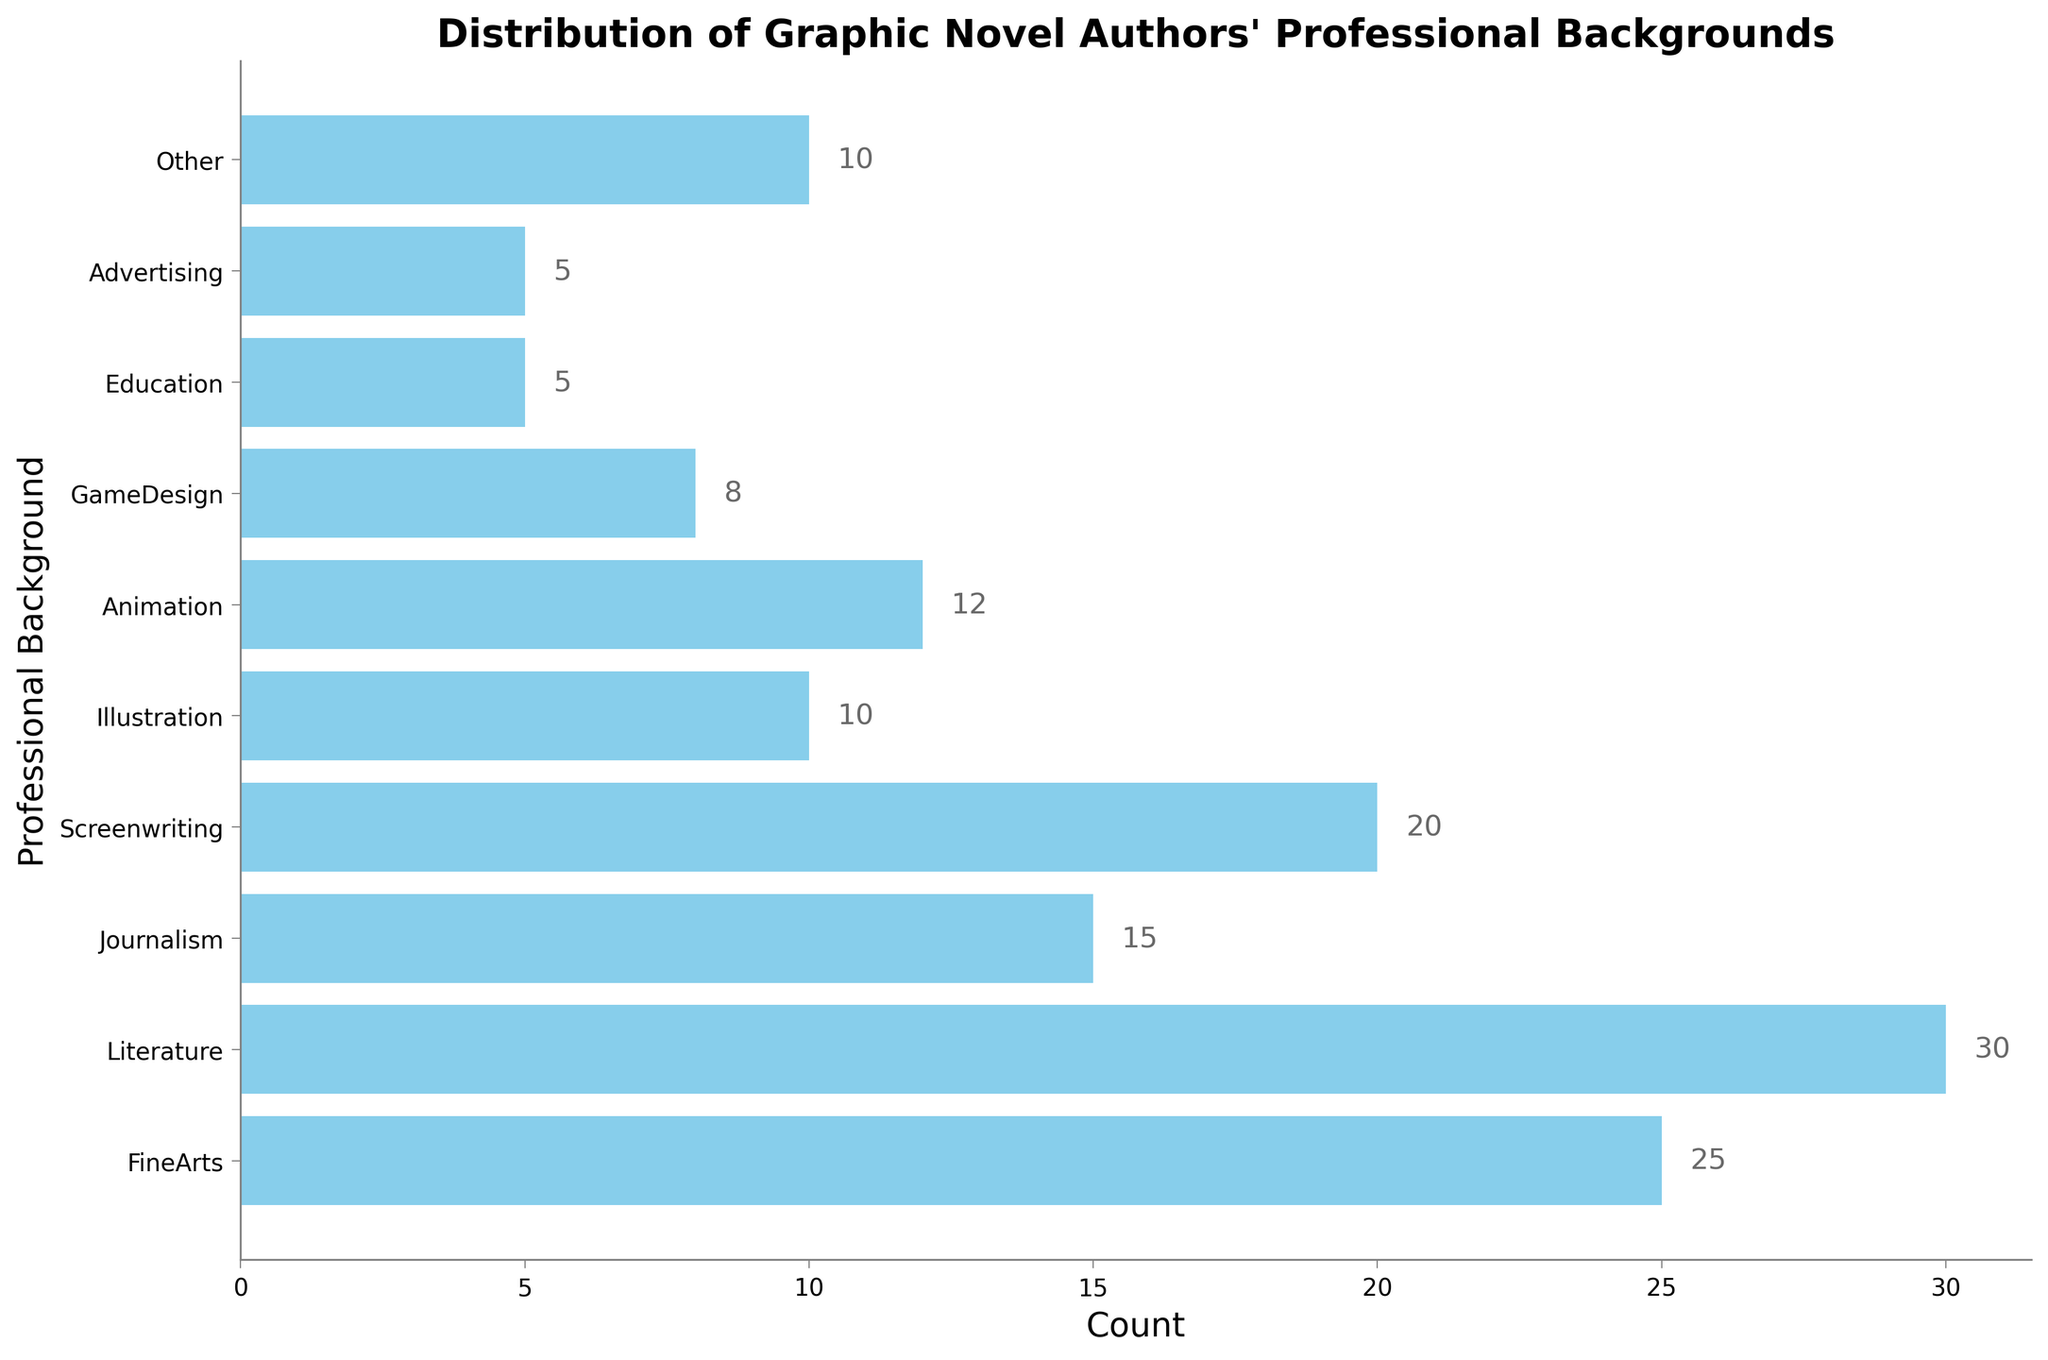What professional background has the highest count? The figure shows that the professional background 'Literature' has the longest bar, indicating the highest count.
Answer: Literature Which two professional backgrounds have the smallest counts, and are their counts equal? From the figure, 'Education' and 'Advertising' have the shortest bars, both showing a count of 5, so they have equal counts.
Answer: Education and Advertising, Yes What is the total count of authors coming from Screenwriting, FineArts, and Journalism? From the figure, Screenwriting has a count of 20, FineArts has a count of 25, and Journalism has a count of 15. Summing these up: 20 + 25 + 15 = 60.
Answer: 60 How many more authors come from Literature compared to GameDesign? The figure shows 'Literature' with a count of 30 and 'GameDesign' with a count of 8. The difference is 30 - 8 = 22.
Answer: 22 Which professional background has a count less than Animation but more than Education? From the figure, Animation has a count of 12 and Education has a count of 5. 'Advertising' fits because it has a count of 10, which is between 5 and 12.
Answer: Advertising Are there more authors from Illustration or GameDesign, and by how many? The figure shows Illustration with a count of 10 and GameDesign with a count of 8. The difference is 10 - 8 = 2.
Answer: Illustration, 2 What is the median count of all the professional backgrounds? Listing the counts in ascending order: 5, 5, 8, 10, 10, 12, 15, 20, 25, 30. The median is the average of the 5th and 6th values: (10 + 12)/2 = 11.
Answer: 11 Which professional backgrounds have a count more than 10? From the figure, the professional backgrounds with counts more than 10 are Journalism (15), Animation (12), Screenwriting (20), FineArts (25), and Literature (30).
Answer: Journalism, Animation, Screenwriting, FineArts, Literature What is the difference in counts between the highest and lowest professional backgrounds? The highest professional background is Literature with a count of 30, and the lowest are Education and Advertising, each with a count of 5. The difference is 30 - 5 = 25.
Answer: 25 